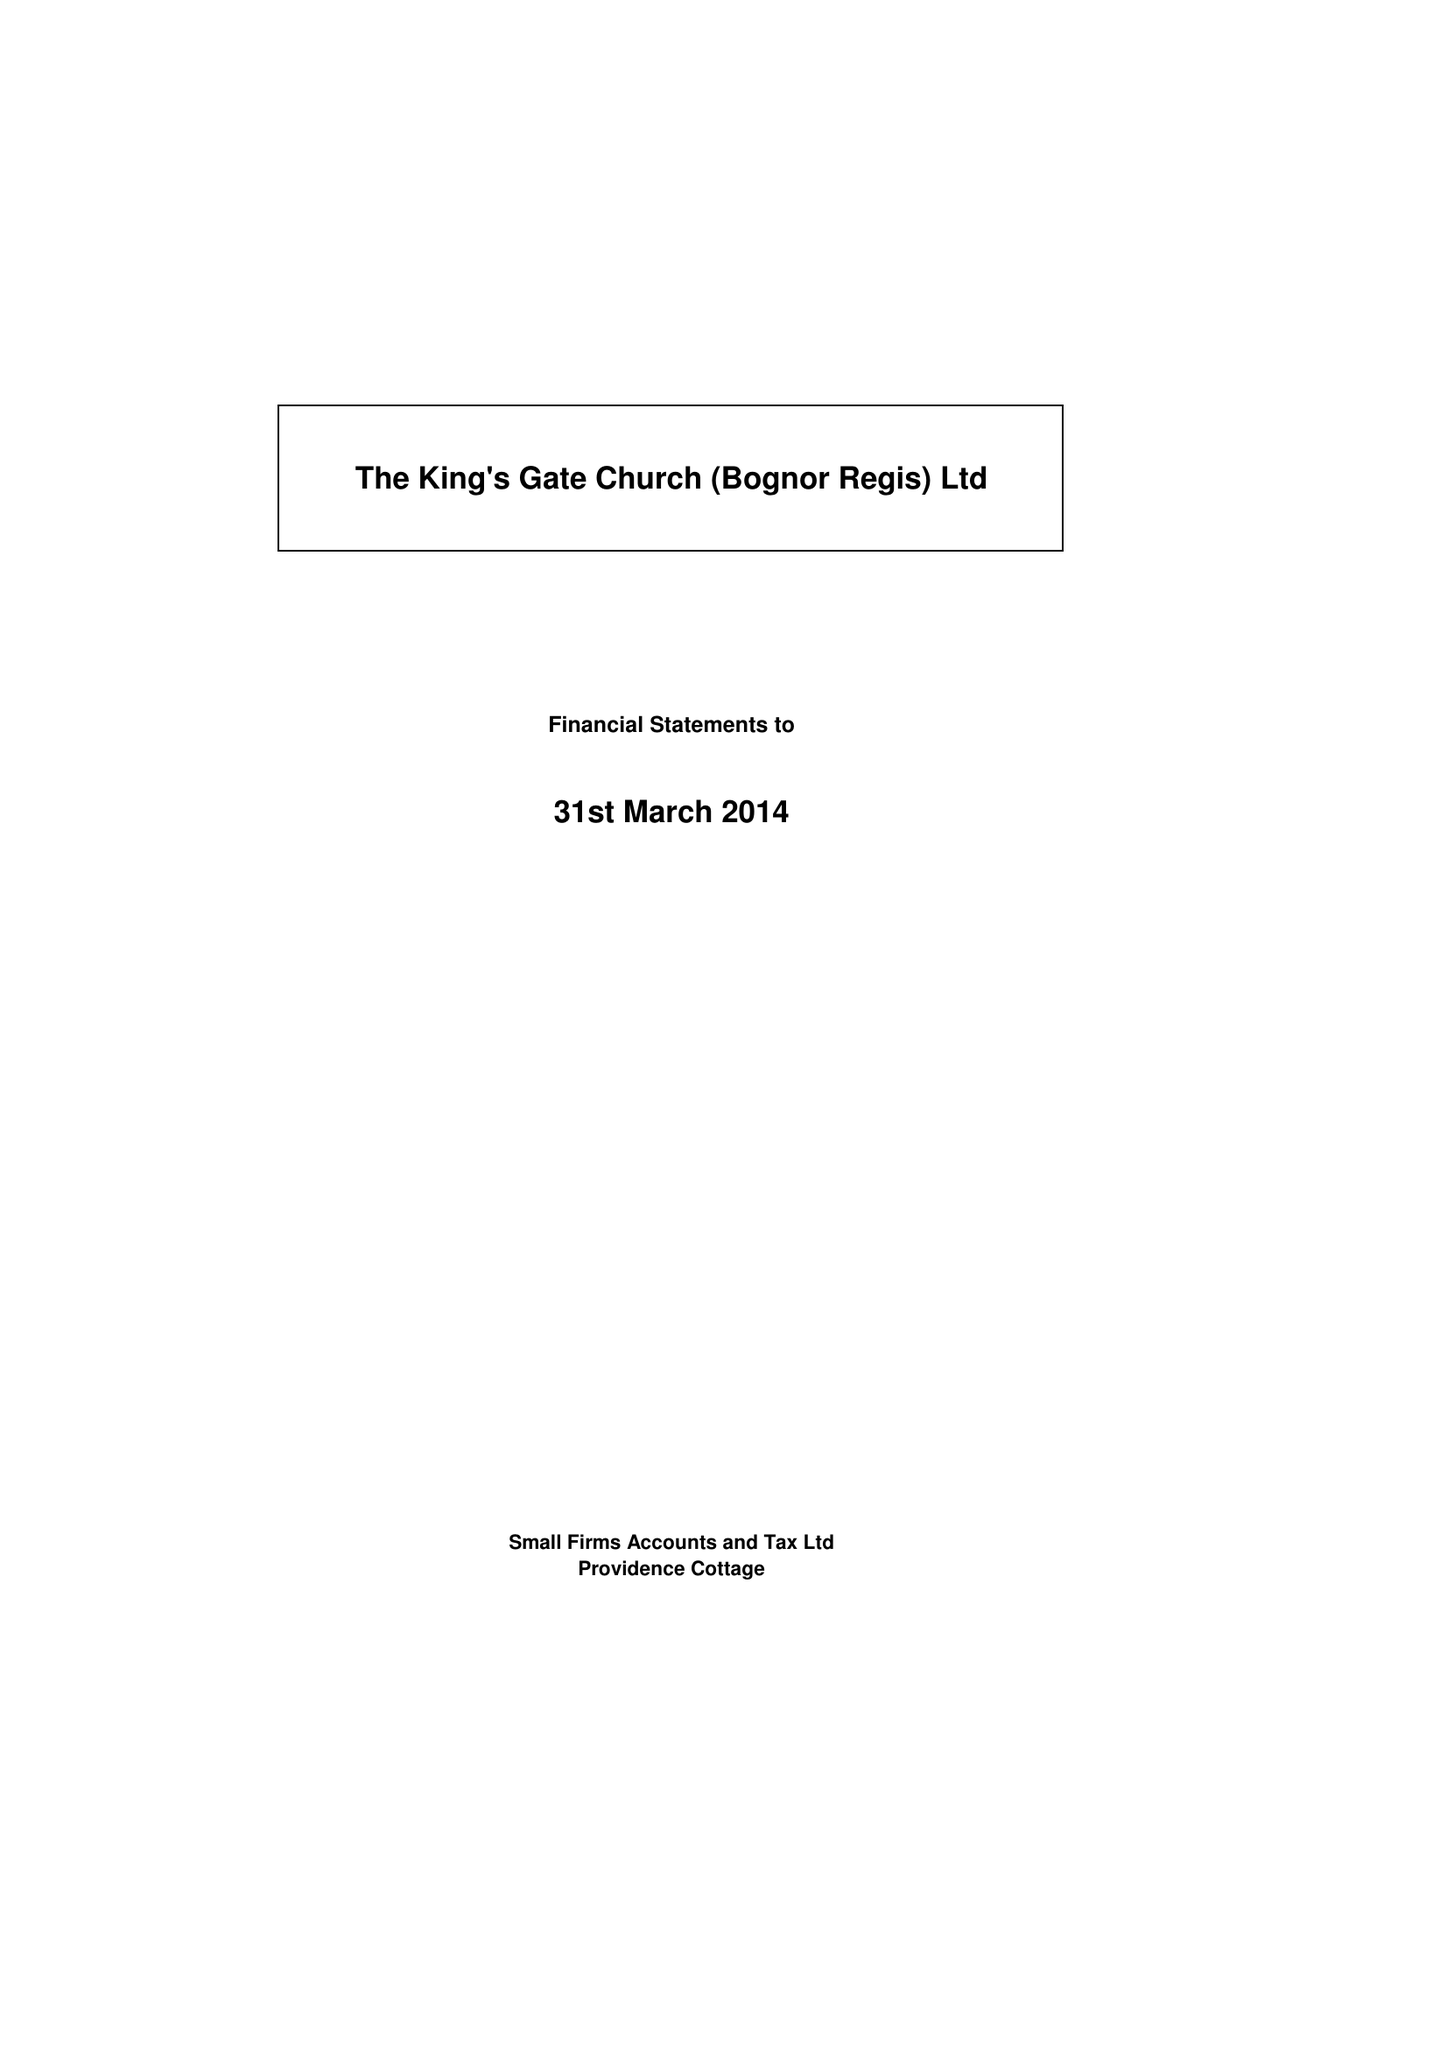What is the value for the charity_name?
Answer the question using a single word or phrase. The King's Gate Church (Bognor Regis) Ltd. 